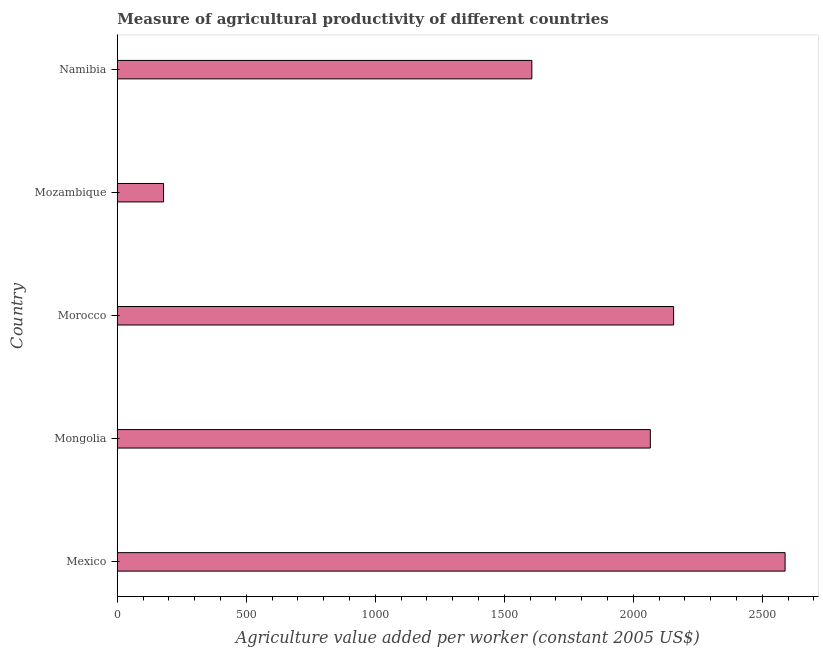Does the graph contain grids?
Provide a succinct answer. No. What is the title of the graph?
Give a very brief answer. Measure of agricultural productivity of different countries. What is the label or title of the X-axis?
Give a very brief answer. Agriculture value added per worker (constant 2005 US$). What is the agriculture value added per worker in Mongolia?
Keep it short and to the point. 2065.99. Across all countries, what is the maximum agriculture value added per worker?
Ensure brevity in your answer.  2588.37. Across all countries, what is the minimum agriculture value added per worker?
Provide a succinct answer. 179.33. In which country was the agriculture value added per worker minimum?
Your answer should be compact. Mozambique. What is the sum of the agriculture value added per worker?
Offer a terse response. 8596.78. What is the difference between the agriculture value added per worker in Mexico and Namibia?
Your answer should be compact. 981.56. What is the average agriculture value added per worker per country?
Provide a short and direct response. 1719.36. What is the median agriculture value added per worker?
Ensure brevity in your answer.  2065.99. In how many countries, is the agriculture value added per worker greater than 200 US$?
Your response must be concise. 4. What is the ratio of the agriculture value added per worker in Morocco to that in Mozambique?
Offer a terse response. 12.02. Is the difference between the agriculture value added per worker in Mongolia and Morocco greater than the difference between any two countries?
Your answer should be compact. No. What is the difference between the highest and the second highest agriculture value added per worker?
Ensure brevity in your answer.  432.09. Is the sum of the agriculture value added per worker in Morocco and Mozambique greater than the maximum agriculture value added per worker across all countries?
Offer a very short reply. No. What is the difference between the highest and the lowest agriculture value added per worker?
Provide a succinct answer. 2409.03. In how many countries, is the agriculture value added per worker greater than the average agriculture value added per worker taken over all countries?
Keep it short and to the point. 3. Are all the bars in the graph horizontal?
Your answer should be very brief. Yes. How many countries are there in the graph?
Make the answer very short. 5. What is the Agriculture value added per worker (constant 2005 US$) of Mexico?
Your answer should be compact. 2588.37. What is the Agriculture value added per worker (constant 2005 US$) of Mongolia?
Your answer should be very brief. 2065.99. What is the Agriculture value added per worker (constant 2005 US$) of Morocco?
Your answer should be compact. 2156.28. What is the Agriculture value added per worker (constant 2005 US$) in Mozambique?
Make the answer very short. 179.33. What is the Agriculture value added per worker (constant 2005 US$) in Namibia?
Make the answer very short. 1606.81. What is the difference between the Agriculture value added per worker (constant 2005 US$) in Mexico and Mongolia?
Give a very brief answer. 522.38. What is the difference between the Agriculture value added per worker (constant 2005 US$) in Mexico and Morocco?
Give a very brief answer. 432.09. What is the difference between the Agriculture value added per worker (constant 2005 US$) in Mexico and Mozambique?
Your response must be concise. 2409.03. What is the difference between the Agriculture value added per worker (constant 2005 US$) in Mexico and Namibia?
Ensure brevity in your answer.  981.56. What is the difference between the Agriculture value added per worker (constant 2005 US$) in Mongolia and Morocco?
Make the answer very short. -90.29. What is the difference between the Agriculture value added per worker (constant 2005 US$) in Mongolia and Mozambique?
Provide a short and direct response. 1886.66. What is the difference between the Agriculture value added per worker (constant 2005 US$) in Mongolia and Namibia?
Give a very brief answer. 459.18. What is the difference between the Agriculture value added per worker (constant 2005 US$) in Morocco and Mozambique?
Your answer should be very brief. 1976.94. What is the difference between the Agriculture value added per worker (constant 2005 US$) in Morocco and Namibia?
Your answer should be compact. 549.47. What is the difference between the Agriculture value added per worker (constant 2005 US$) in Mozambique and Namibia?
Offer a very short reply. -1427.47. What is the ratio of the Agriculture value added per worker (constant 2005 US$) in Mexico to that in Mongolia?
Provide a short and direct response. 1.25. What is the ratio of the Agriculture value added per worker (constant 2005 US$) in Mexico to that in Mozambique?
Ensure brevity in your answer.  14.43. What is the ratio of the Agriculture value added per worker (constant 2005 US$) in Mexico to that in Namibia?
Provide a short and direct response. 1.61. What is the ratio of the Agriculture value added per worker (constant 2005 US$) in Mongolia to that in Morocco?
Provide a succinct answer. 0.96. What is the ratio of the Agriculture value added per worker (constant 2005 US$) in Mongolia to that in Mozambique?
Provide a short and direct response. 11.52. What is the ratio of the Agriculture value added per worker (constant 2005 US$) in Mongolia to that in Namibia?
Your answer should be compact. 1.29. What is the ratio of the Agriculture value added per worker (constant 2005 US$) in Morocco to that in Mozambique?
Offer a very short reply. 12.02. What is the ratio of the Agriculture value added per worker (constant 2005 US$) in Morocco to that in Namibia?
Offer a very short reply. 1.34. What is the ratio of the Agriculture value added per worker (constant 2005 US$) in Mozambique to that in Namibia?
Your answer should be compact. 0.11. 